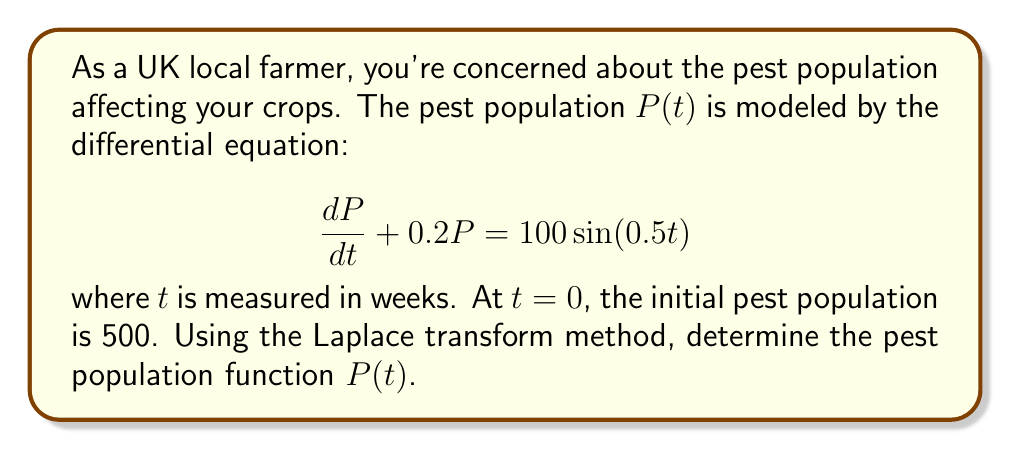Can you solve this math problem? Let's solve this problem using the Laplace transform method:

1) First, take the Laplace transform of both sides of the equation:

   $\mathcal{L}\{\frac{dP}{dt} + 0.2P\} = \mathcal{L}\{100\sin(0.5t)\}$

2) Using Laplace transform properties:

   $s\mathcal{L}\{P\} - P(0) + 0.2\mathcal{L}\{P\} = \frac{100 \cdot 0.5}{s^2 + 0.5^2}$

3) Let $\mathcal{L}\{P\} = F(s)$. Substituting the initial condition $P(0) = 500$:

   $sF(s) - 500 + 0.2F(s) = \frac{50}{s^2 + 0.25}$

4) Rearranging terms:

   $(s + 0.2)F(s) = 500 + \frac{50}{s^2 + 0.25}$

5) Solving for $F(s)$:

   $F(s) = \frac{500}{s + 0.2} + \frac{50}{(s + 0.2)(s^2 + 0.25)}$

6) Decompose the second term using partial fractions:

   $\frac{50}{(s + 0.2)(s^2 + 0.25)} = \frac{A}{s + 0.2} + \frac{Bs + C}{s^2 + 0.25}$

7) Solve for $A$, $B$, and $C$:

   $A = 200$, $B = -200$, $C = 40$

8) Rewrite $F(s)$:

   $F(s) = \frac{700}{s + 0.2} + \frac{-200s + 40}{s^2 + 0.25}$

9) Take the inverse Laplace transform:

   $P(t) = 700e^{-0.2t} - 200\cos(0.5t) + 80\sin(0.5t)$

This is the pest population function $P(t)$.
Answer: $P(t) = 700e^{-0.2t} - 200\cos(0.5t) + 80\sin(0.5t)$ 